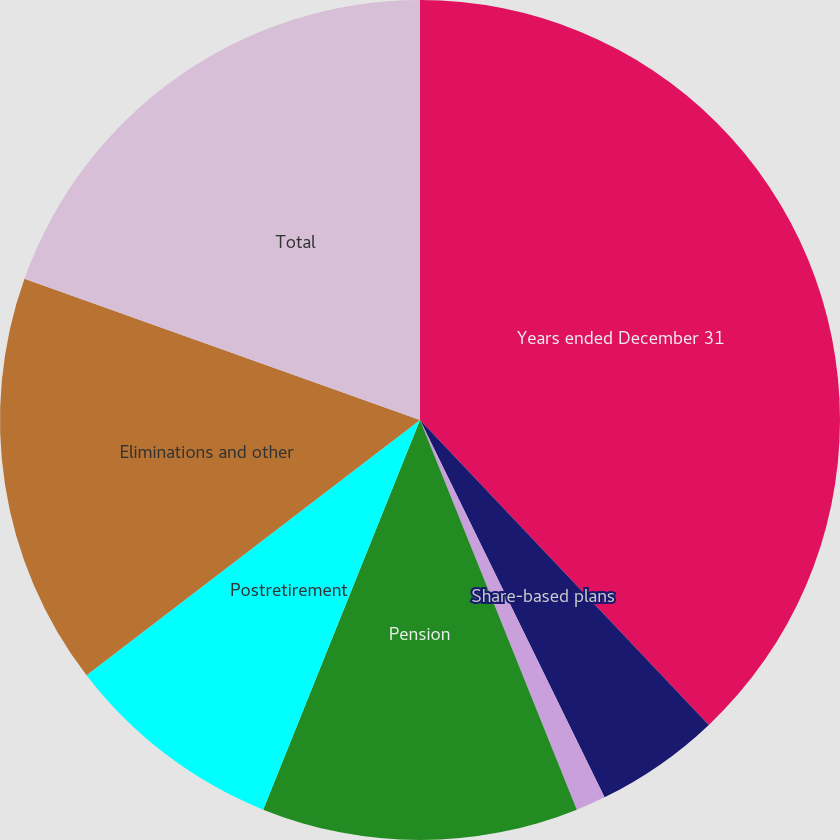Convert chart to OTSL. <chart><loc_0><loc_0><loc_500><loc_500><pie_chart><fcel>Years ended December 31<fcel>Share-based plans<fcel>Deferred compensation<fcel>Pension<fcel>Postretirement<fcel>Eliminations and other<fcel>Total<nl><fcel>37.93%<fcel>4.83%<fcel>1.15%<fcel>12.18%<fcel>8.51%<fcel>15.86%<fcel>19.54%<nl></chart> 